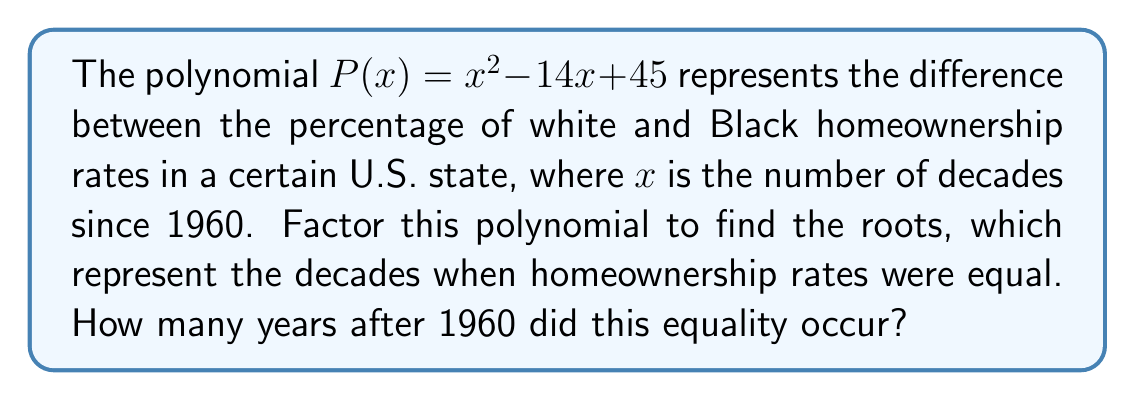Show me your answer to this math problem. To solve this problem, we'll follow these steps:

1) First, we need to factor the polynomial $P(x) = x^2 - 14x + 45$

2) We can use the quadratic formula or factoring by grouping. Let's use factoring:
   
   We're looking for two numbers that multiply to give 45 and add to give -14.
   These numbers are -9 and -5.

3) So, we can rewrite the polynomial as:

   $P(x) = (x - 9)(x - 5)$

4) The roots of this polynomial are the values of $x$ that make $P(x) = 0$
   This occurs when either $(x - 9) = 0$ or $(x - 5) = 0$

5) Solving these:
   $x - 9 = 0$ gives $x = 9$
   $x - 5 = 0$ gives $x = 5$

6) Remember, $x$ represents the number of decades since 1960.
   So, $x = 5$ represents 5 decades after 1960, which is 2010
   And $x = 9$ represents 9 decades after 1960, which is 2050

7) The question asks for years after 1960, not decades.
   5 decades = 50 years
   9 decades = 90 years

8) The earlier of these two dates is 2010, which is 50 years after 1960.
Answer: 50 years 